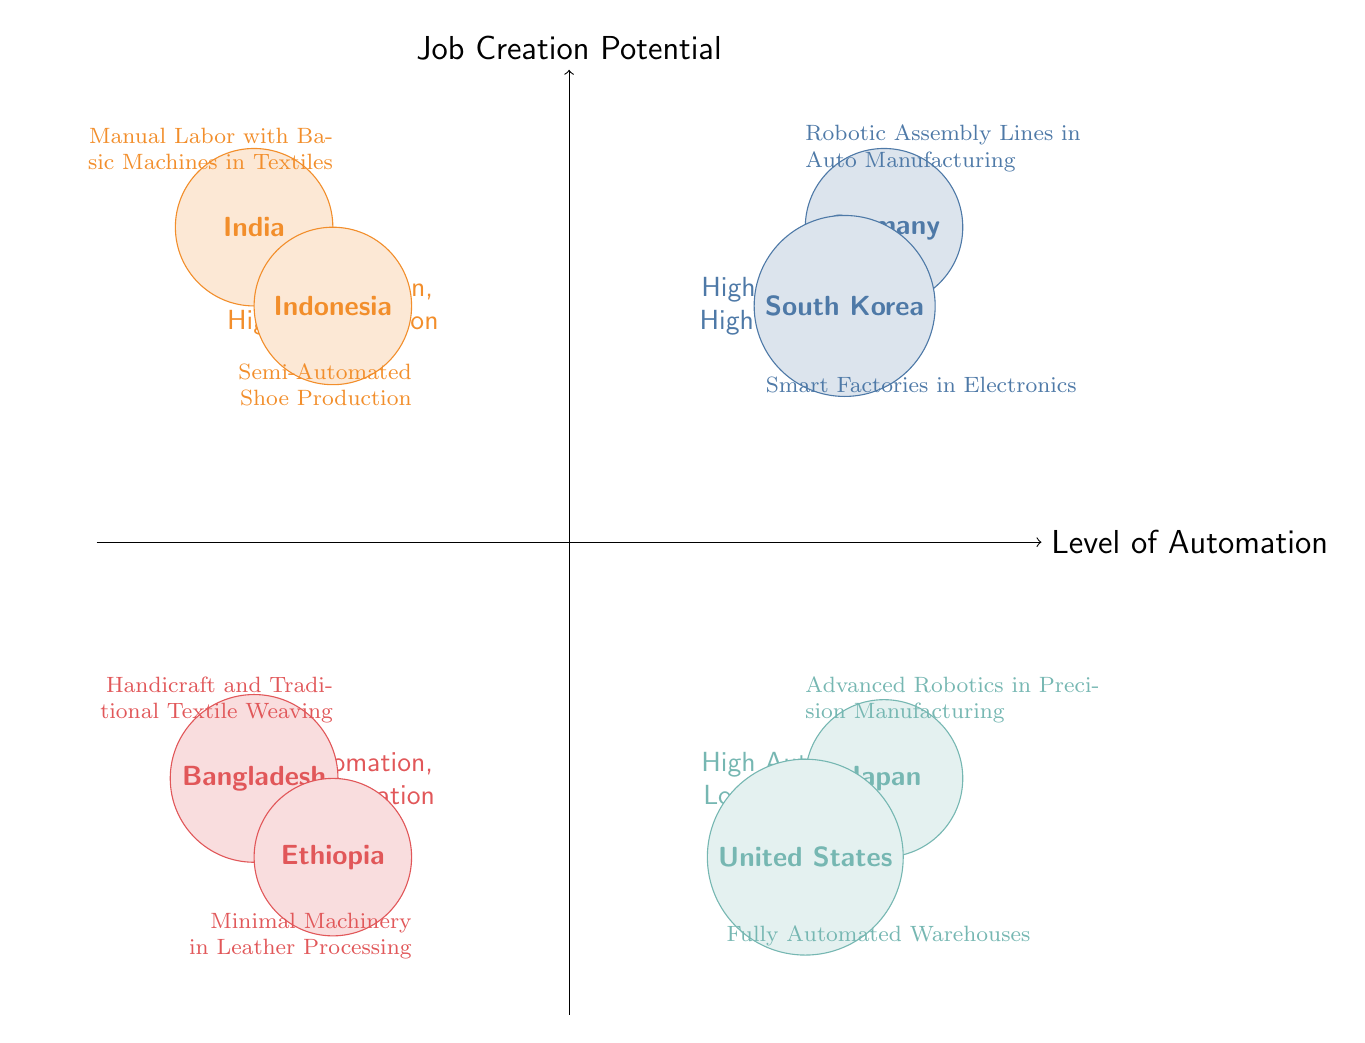What countries are in the High Automation, High Job Creation quadrant? The High Automation, High Job Creation quadrant has two countries: Germany and South Korea. This can be determined by examining the labels and positions of the nodes in that quadrant.
Answer: Germany, South Korea What type of automation is used in Japan? In the diagram, Japan is located in the High Automation, Low Job Creation quadrant, and it is noted for using Advanced Robotics in Precision Manufacturing. This specific information is labeled next to Japan's node.
Answer: Advanced Robotics in Precision Manufacturing What is the job creation potential in Indonesia? Indonesia is positioned in the Low Automation, High Job Creation quadrant and is associated with a high number of entry-level jobs created, as indicated next to the country’s label. Thus, to answer the question, one must refer to the details provided next to Indonesia’s node.
Answer: High Number of Entry-Level Jobs Which quadrant has the least potential for job creation? To find the quadrant with the least potential for job creation, one needs to compare the quadrants based on the job creation potential explained in the diagram. The Low Automation, Low Job Creation quadrant has countries with few new job opportunities, indicating the least potential overall.
Answer: Low Automation, Low Job Creation How many countries are represented in the Low Automation, High Job Creation quadrant? The Low Automation, High Job Creation quadrant contains two countries: India and Indonesia. This is determined by counting the nodes in that specific quadrant.
Answer: 2 